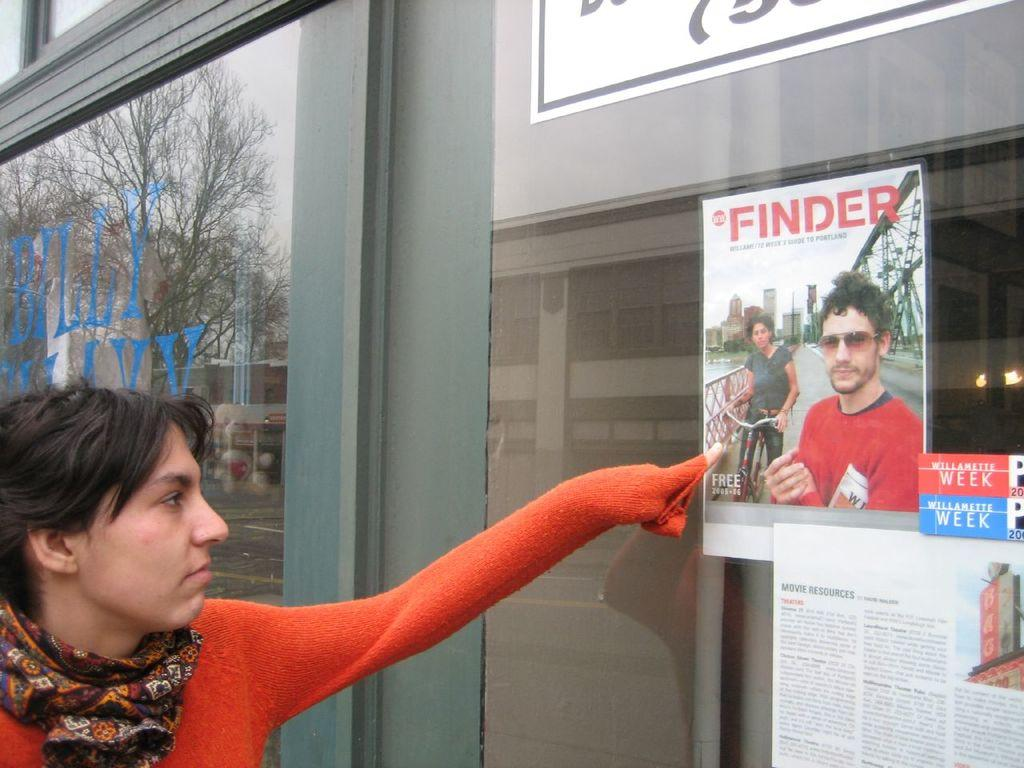What is the main subject of the image? There is a woman standing in the image. What is the woman doing in the image? The woman is pointing her finger at a poster. How many posters are on the wall in the image? There are two posters on the wall in the image. What type of lake can be seen in the image? There is no lake present in the image. How does the woman start her day in the image? The facts provided do not give any information about the woman's daily routine or how she starts her day. 